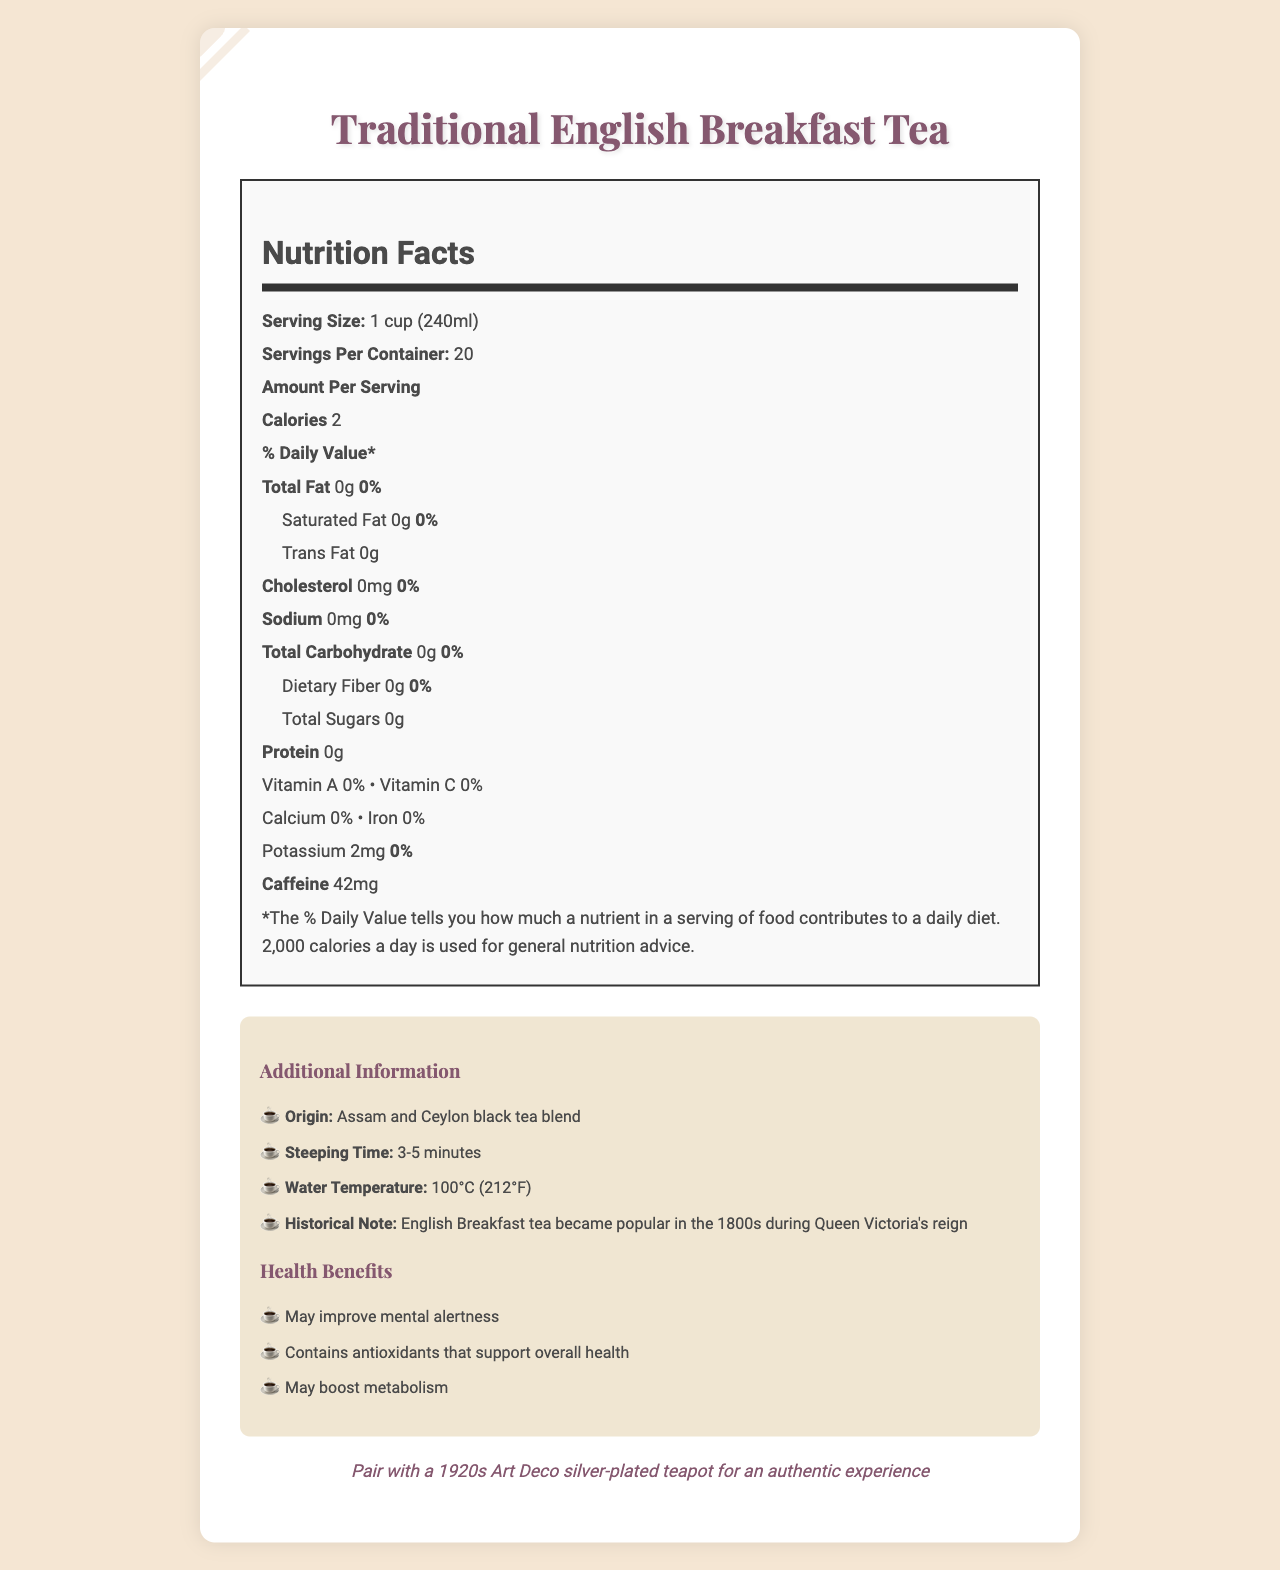what is the serving size for Traditional English Breakfast Tea? The serving size is stated on the label as "1 cup (240ml)".
Answer: 1 cup (240ml) how many servings per container are in the English Breakfast Tea? The label indicates there are 20 servings per container.
Answer: 20 how much caffeine is in one serving of this tea? The label specifies that there are 42mg of caffeine per serving.
Answer: 42mg what vitamins and minerals are listed in the nutrition facts? The document lists Vitamin A, Vitamin C, Calcium, Iron, and Potassium.
Answer: Vitamin A, Vitamin C, Calcium, Iron, Potassium what is the total amount of flavonoids present in the tea? Under the antioxidants section, the label shows there are 150mg of flavonoids.
Answer: 150mg does this tea contain any trans fat? The label states that there are 0 grams of trans fat.
Answer: No what is the steeping time recommended for this tea? The additional information section recommends a steeping time of 3-5 minutes.
Answer: 3-5 minutes what kind of teapot is suggested to pair with this tea? The vintage note mentions pairing with a 1920s Art Deco silver-plated teapot for an authentic experience.
Answer: 1920s Art Deco silver-plated teapot does the tea contain any calories? The document indicates that one serving of the tea contains 2 calories.
Answer: Yes which of the following health benefits is associated with this tea? A. Enhances immune function B. May improve mental alertness C. Reduces blood pressure D. Promotes dental health The document mentions that one of the health benefits is that it "may improve mental alertness."
Answer: B what is the origin of this Traditional English Breakfast Tea? A. Darjeeling B. Assam and Ceylon C. Yunnan D. Nilgiri The label states that the tea is a blend of Assam and Ceylon black tea.
Answer: B is there any dietary fiber in this tea? The label shows that there is 0 grams of dietary fiber in the tea.
Answer: No what are the main points covered in this document? The document covers the nutrition facts, caffeine content, antioxidants, steeping instructions, origin, historical significance, and suggested teapot pairing for Traditional English Breakfast Tea.
Answer: The document provides detailed nutritional information for Traditional English Breakfast Tea, including its caffeine and antioxidant content, serving size, calories, and health benefits. It also includes additional information such as the tea's origin, steeping time, and a historical note. what is the specific l-theanine content in this tea? The document lists 25mg of l-theanine under the amino acids section.
Answer: 25mg what type of document is this? A. Recipe B. Product Review C. Nutrition Facts Label D. Marketing Flyer The document is identified as a Nutrition Facts Label based on its content and structure.
Answer: C can you determine the price of the Traditional English Breakfast Tea from this document? The document does not provide any information about the price of the tea.
Answer: I don't know 